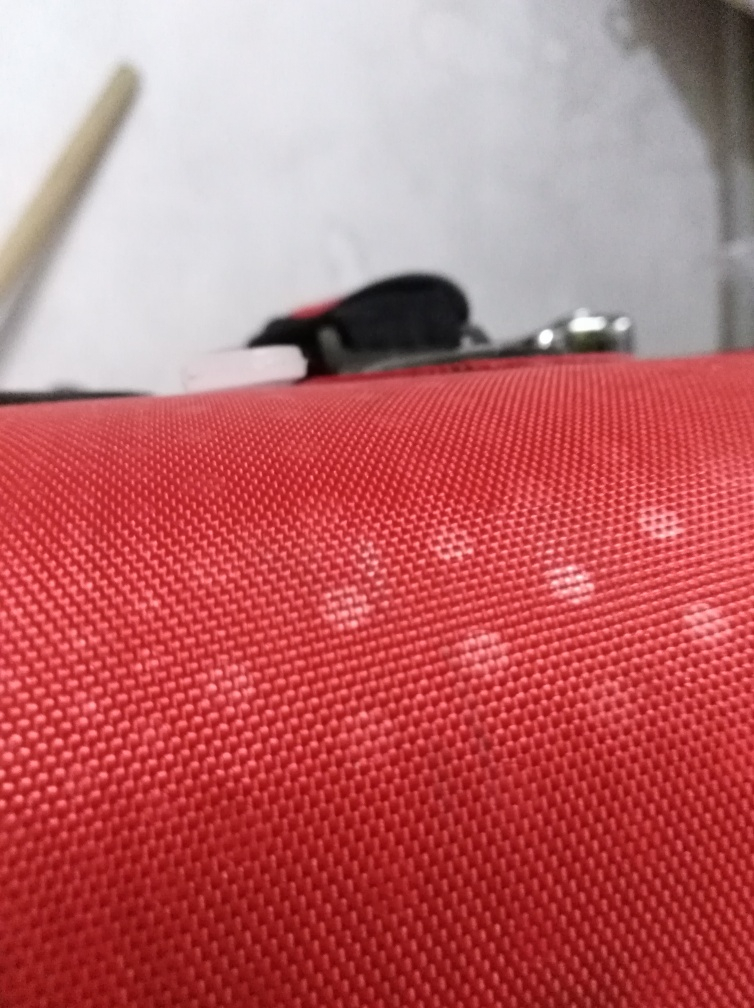Does this picture look like it was taken for a particular reason or just randomly? The composition and quality suggest that the picture may have been taken casually or randomly, rather than with a specific purpose in mind. There's no obvious focal point or subject that stands out, and the overall impression is that it was snapped without deliberate composition or planning. 